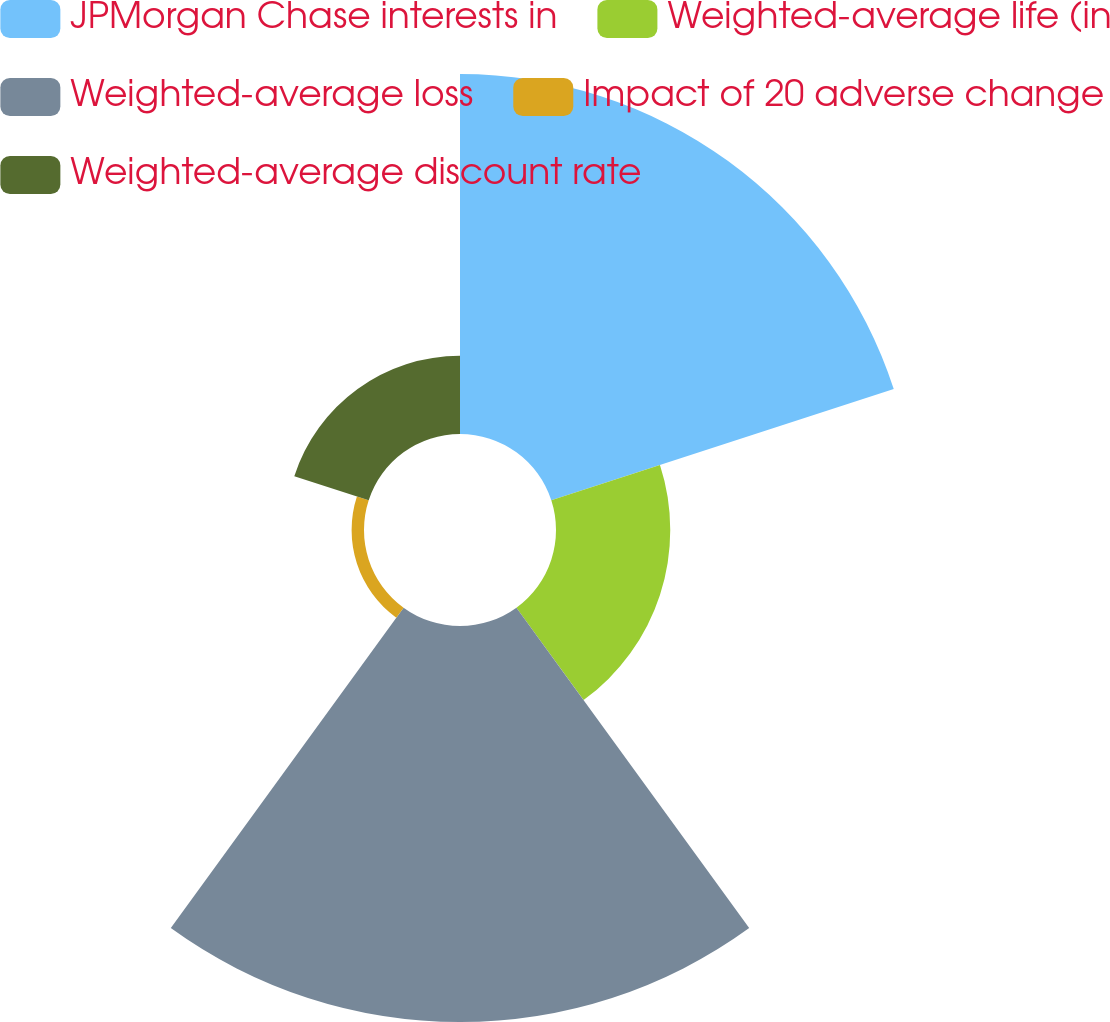<chart> <loc_0><loc_0><loc_500><loc_500><pie_chart><fcel>JPMorgan Chase interests in<fcel>Weighted-average life (in<fcel>Weighted-average loss<fcel>Impact of 20 adverse change<fcel>Weighted-average discount rate<nl><fcel>37.47%<fcel>11.89%<fcel>41.21%<fcel>1.29%<fcel>8.14%<nl></chart> 